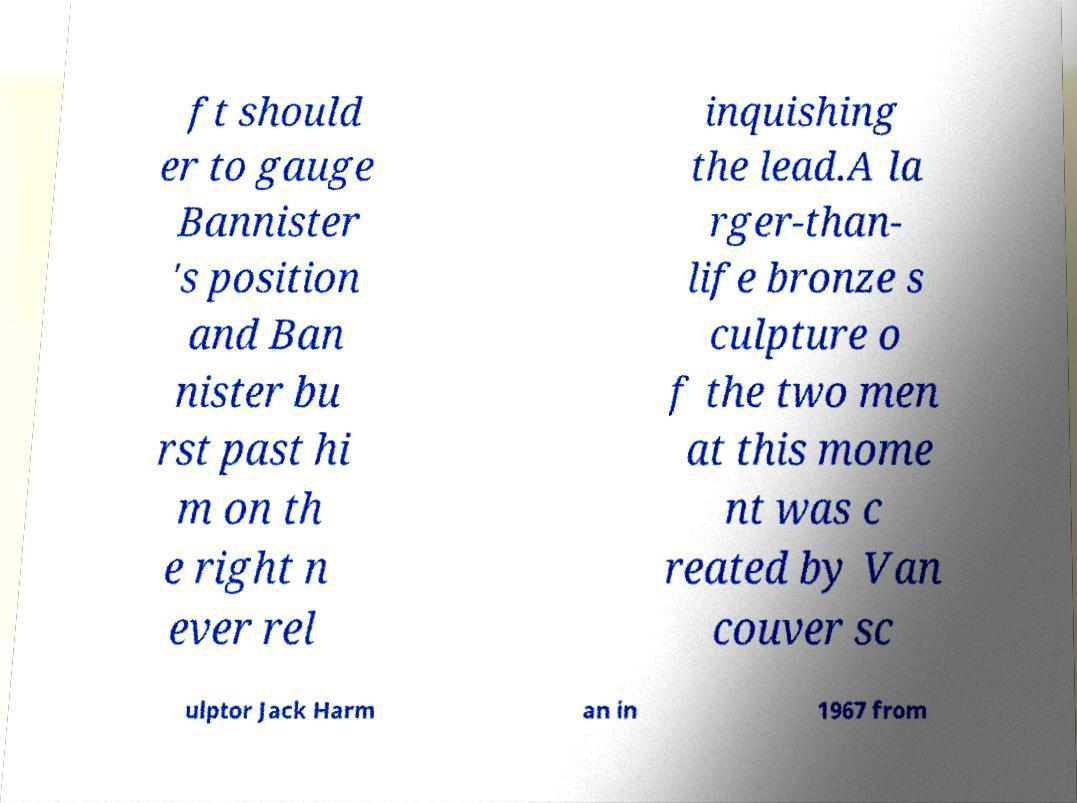Could you assist in decoding the text presented in this image and type it out clearly? ft should er to gauge Bannister 's position and Ban nister bu rst past hi m on th e right n ever rel inquishing the lead.A la rger-than- life bronze s culpture o f the two men at this mome nt was c reated by Van couver sc ulptor Jack Harm an in 1967 from 